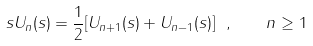Convert formula to latex. <formula><loc_0><loc_0><loc_500><loc_500>s U _ { n } ( s ) = \frac { 1 } { 2 } [ U _ { n + 1 } ( s ) + U _ { n - 1 } ( s ) ] \ , \quad n \geq 1</formula> 